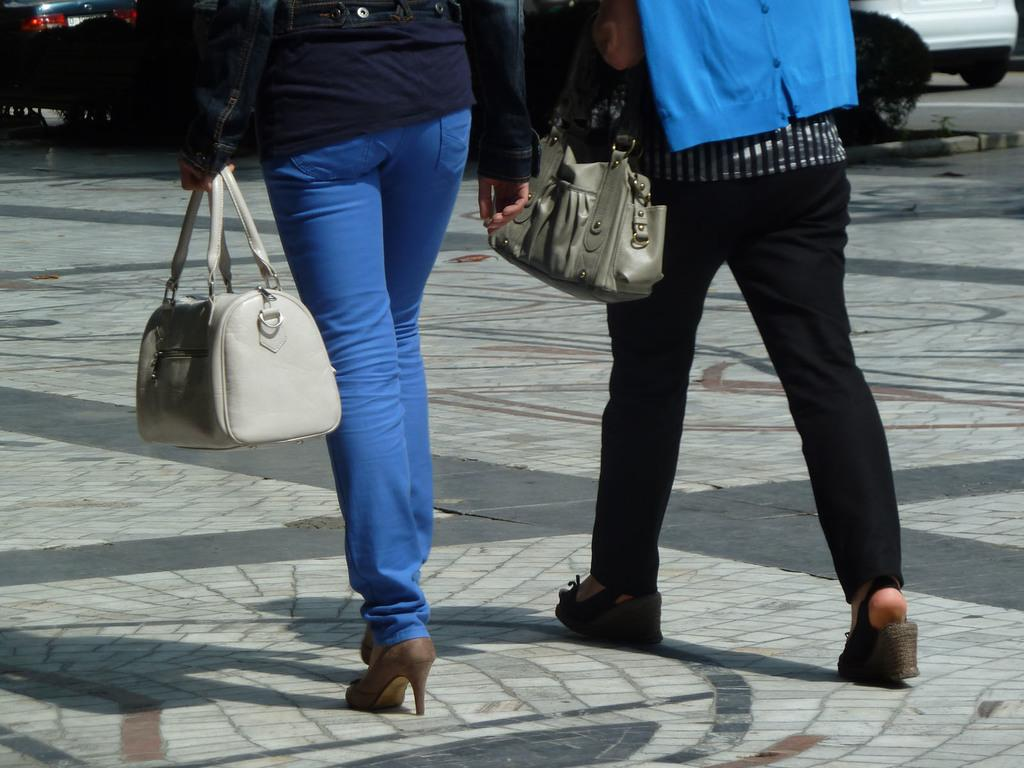How many people are in the image? There are two persons in the image. What are the two persons doing in the image? The two persons are walking. What are they holding in their left hands? Each person is carrying a handbag in their left hand. What type of yak can be seen in the image? There is no yak present in the image. What is the frame of the image made of? The frame of the image is not visible in the provided facts, so we cannot determine its material. 